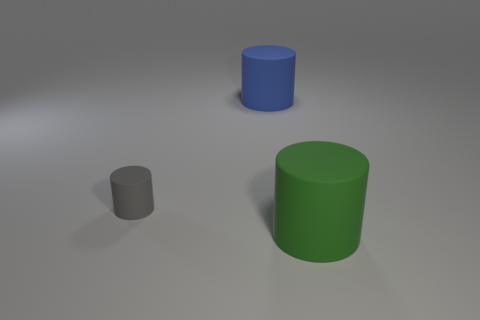How many big green cylinders have the same material as the big green thing?
Your response must be concise. 0. What is the material of the gray cylinder?
Your answer should be very brief. Rubber. There is a big matte thing that is on the right side of the large blue thing that is behind the big green matte cylinder; what shape is it?
Give a very brief answer. Cylinder. There is a gray matte object behind the large green cylinder; what is its shape?
Your answer should be compact. Cylinder. What is the color of the small rubber cylinder?
Your answer should be very brief. Gray. There is a cylinder in front of the small matte cylinder; what number of tiny gray matte cylinders are in front of it?
Ensure brevity in your answer.  0. There is a gray cylinder; is it the same size as the matte cylinder on the right side of the large blue rubber object?
Your answer should be compact. No. Does the green matte cylinder have the same size as the gray matte cylinder?
Ensure brevity in your answer.  No. Are there any yellow metal cubes that have the same size as the blue cylinder?
Your answer should be compact. No. There is a large object that is behind the green thing; what is it made of?
Make the answer very short. Rubber. 